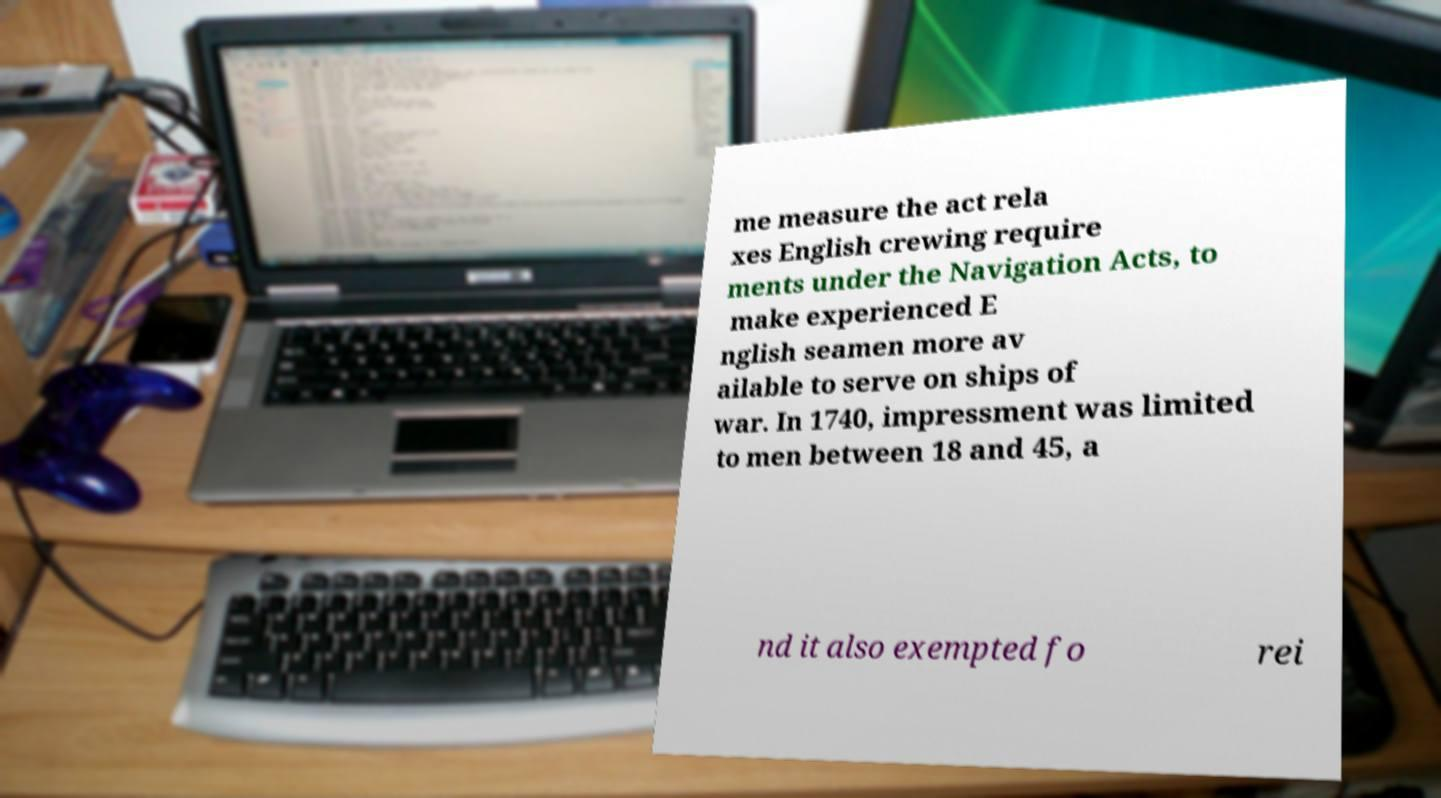Could you assist in decoding the text presented in this image and type it out clearly? me measure the act rela xes English crewing require ments under the Navigation Acts, to make experienced E nglish seamen more av ailable to serve on ships of war. In 1740, impressment was limited to men between 18 and 45, a nd it also exempted fo rei 